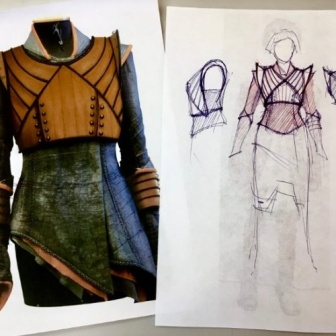What could be the occasion for wearing such a dress based on its design? This dress, with its unique blend of bold and elegant elements, could likely be worn at events where fashion makes a statement, such as costume parties, themed events, or avant-garde fashion shows. Its distinctive style might also appeal to those in the entertainment industry, such as for a character in a stage production or film that requires a look that is powerful yet refined, with a touch of fantasy. 